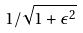<formula> <loc_0><loc_0><loc_500><loc_500>1 / \sqrt { 1 + \epsilon ^ { 2 } }</formula> 